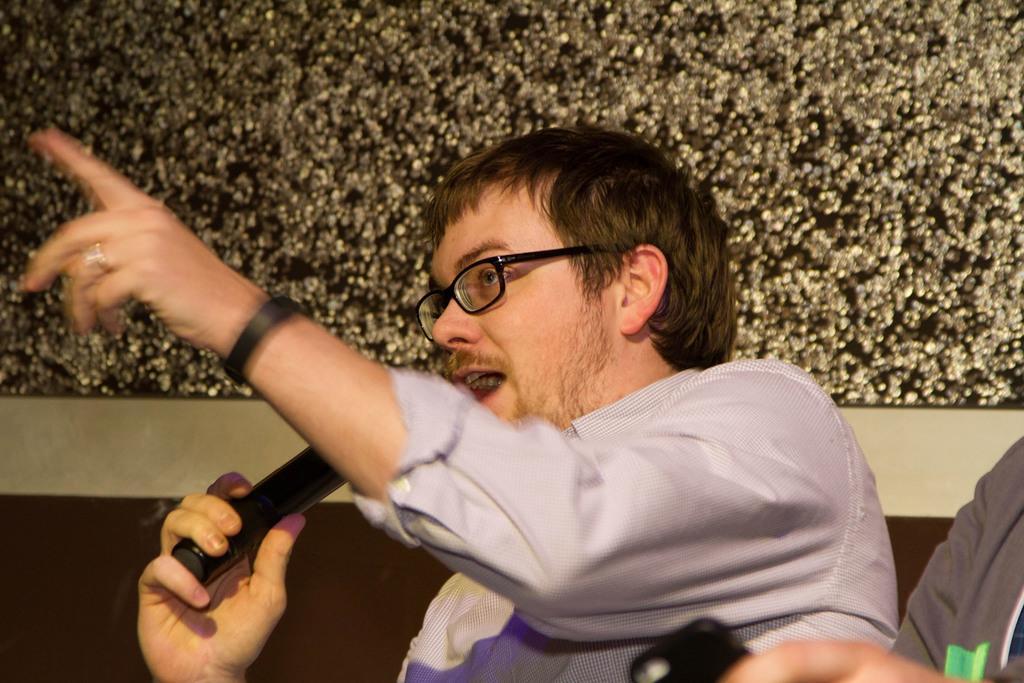How would you summarize this image in a sentence or two? In this picture there is a man who is wearing spectacle, watch, shirt and holding a mic. He is sitting on the couch I can see the person's hand who is wearing t-shirt and holding a mobile phone. At the top I can see the wall. 